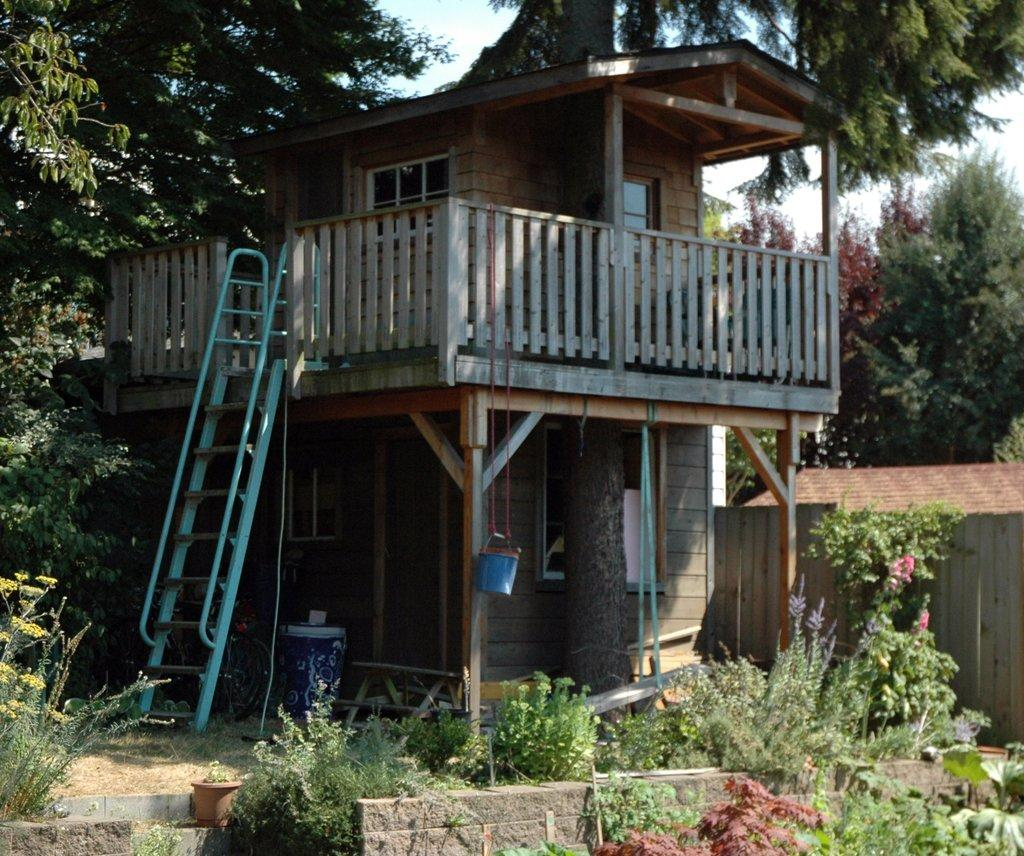What type of structure is visible in the image? There is a house in the image. What can be seen in the background of the image? There are trees in the background of the image. What is located in front of the house? Plants are present in front of the house. What type of popcorn is being served in the image? There is no popcorn present in the image. 